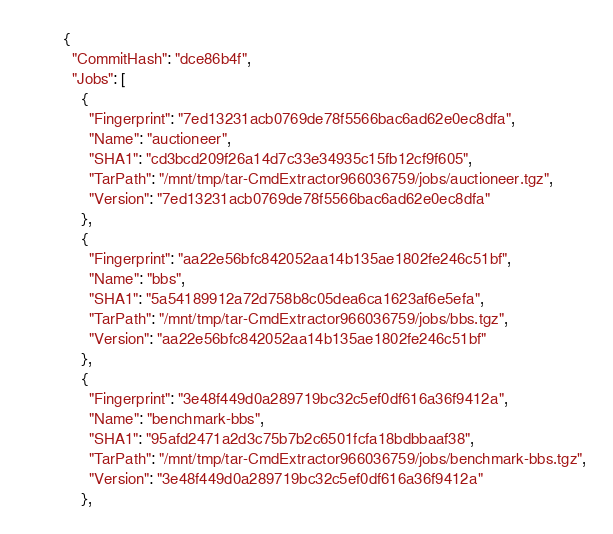<code> <loc_0><loc_0><loc_500><loc_500><_YAML_>{
  "CommitHash": "dce86b4f",
  "Jobs": [
    {
      "Fingerprint": "7ed13231acb0769de78f5566bac6ad62e0ec8dfa",
      "Name": "auctioneer",
      "SHA1": "cd3bcd209f26a14d7c33e34935c15fb12cf9f605",
      "TarPath": "/mnt/tmp/tar-CmdExtractor966036759/jobs/auctioneer.tgz",
      "Version": "7ed13231acb0769de78f5566bac6ad62e0ec8dfa"
    },
    {
      "Fingerprint": "aa22e56bfc842052aa14b135ae1802fe246c51bf",
      "Name": "bbs",
      "SHA1": "5a54189912a72d758b8c05dea6ca1623af6e5efa",
      "TarPath": "/mnt/tmp/tar-CmdExtractor966036759/jobs/bbs.tgz",
      "Version": "aa22e56bfc842052aa14b135ae1802fe246c51bf"
    },
    {
      "Fingerprint": "3e48f449d0a289719bc32c5ef0df616a36f9412a",
      "Name": "benchmark-bbs",
      "SHA1": "95afd2471a2d3c75b7b2c6501fcfa18bdbbaaf38",
      "TarPath": "/mnt/tmp/tar-CmdExtractor966036759/jobs/benchmark-bbs.tgz",
      "Version": "3e48f449d0a289719bc32c5ef0df616a36f9412a"
    },</code> 